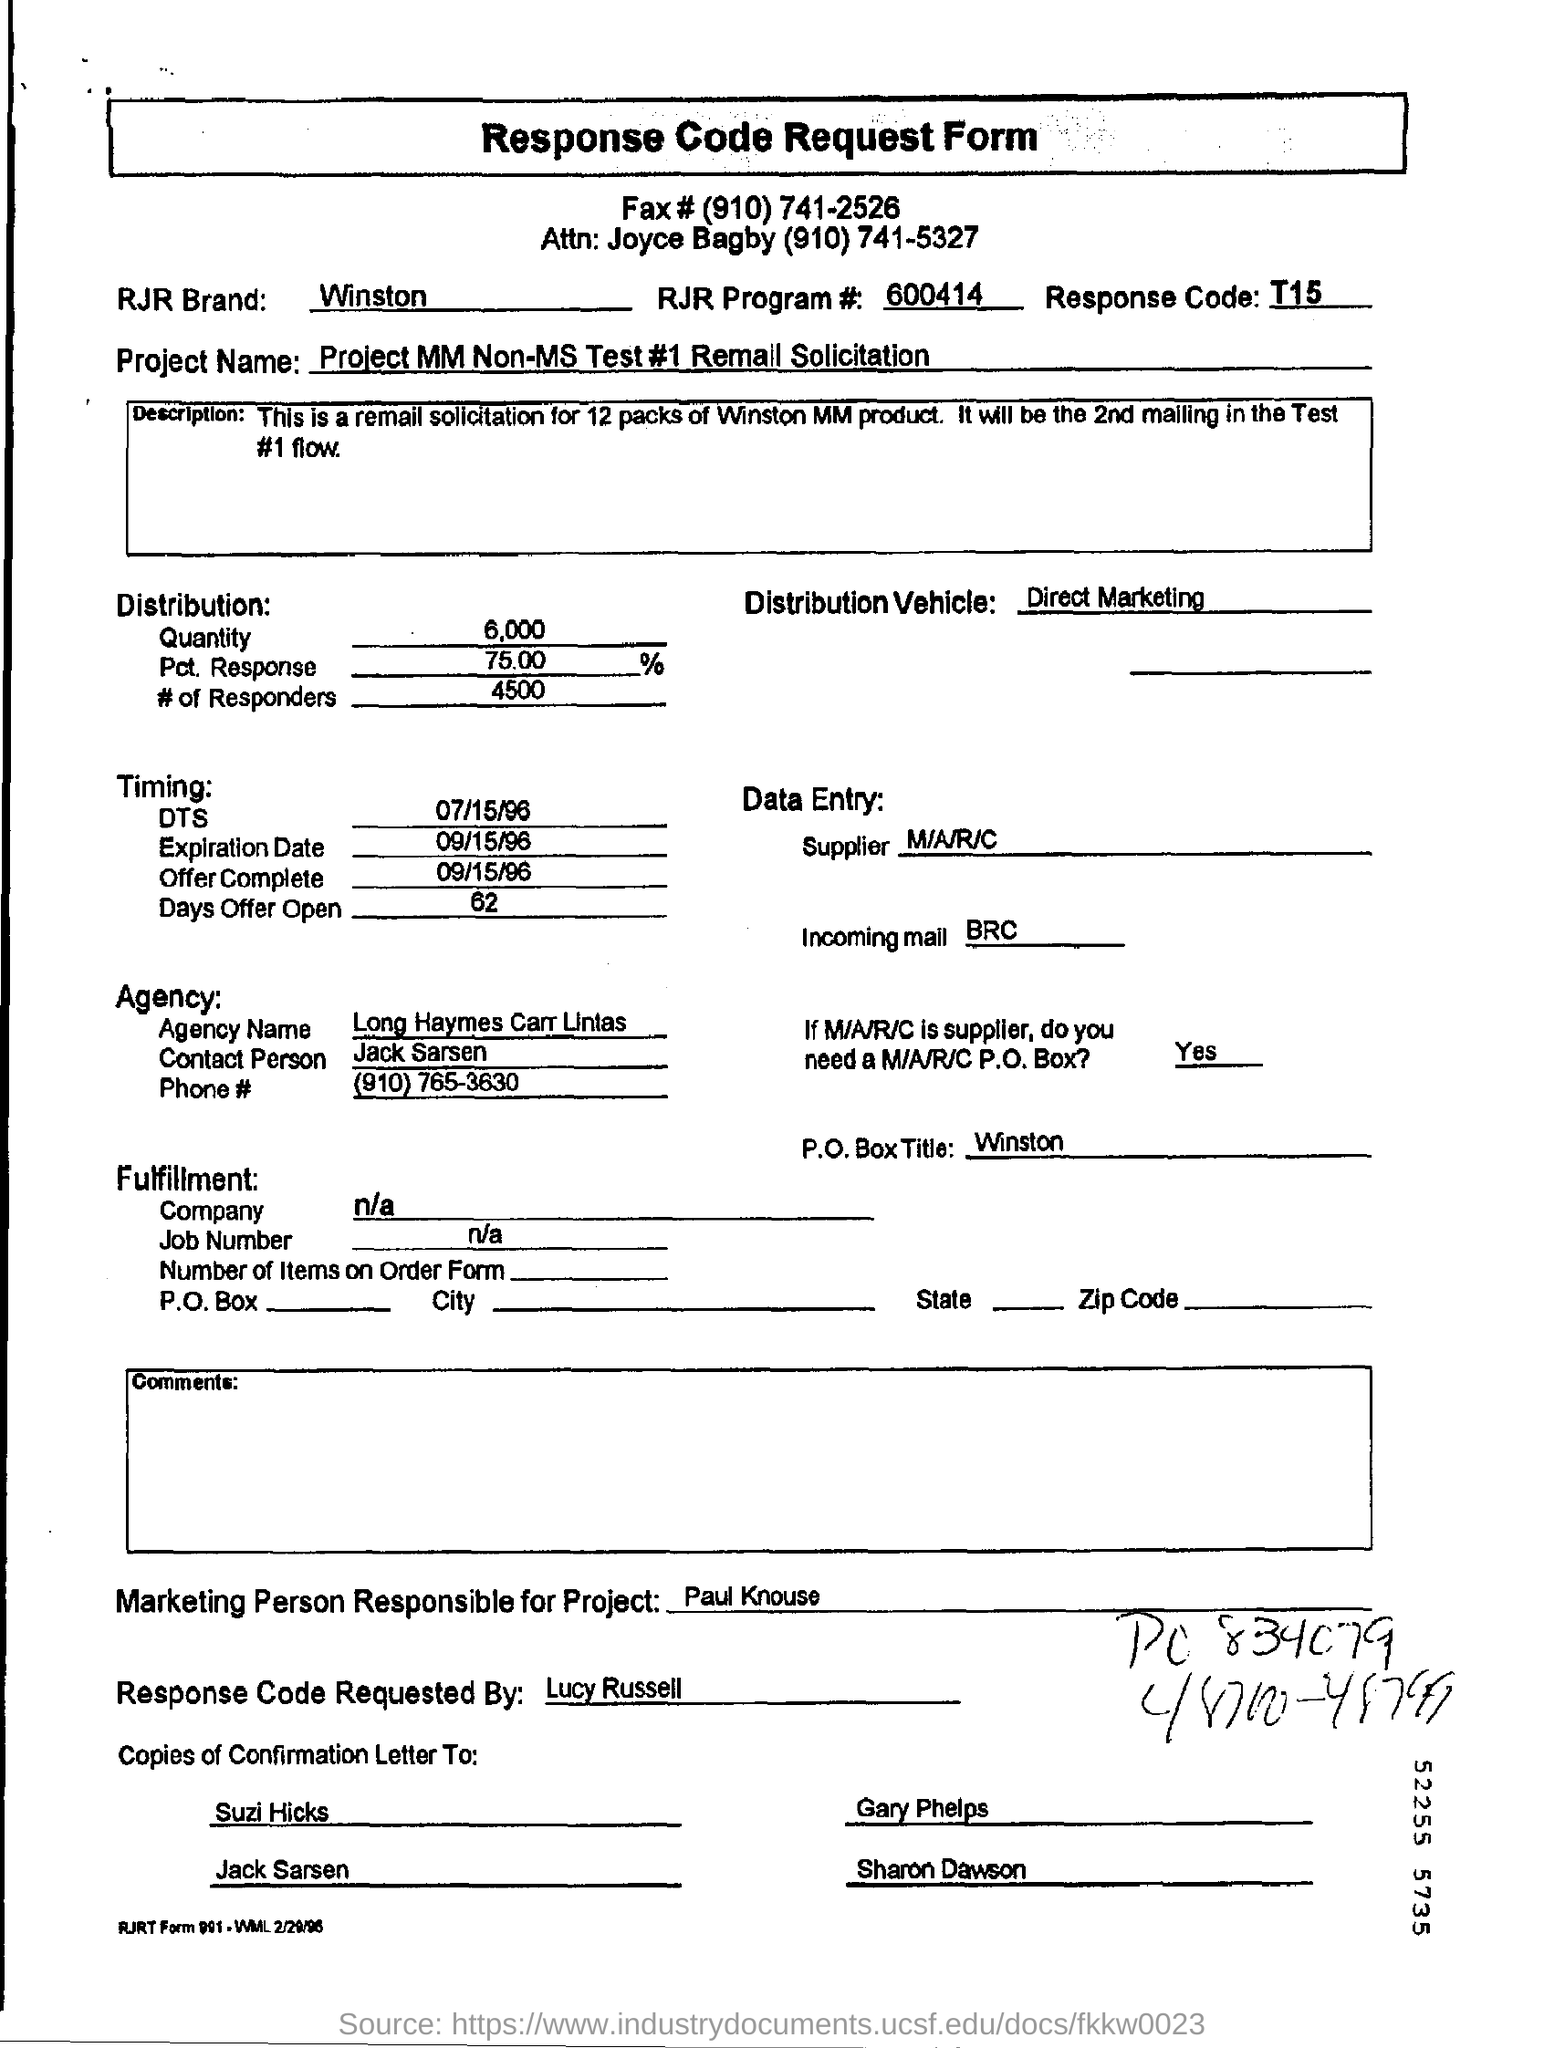List a handful of essential elements in this visual. The project name is "Remall Solicitation #1 for Non-MS Project in MM. The person responsible for project marketing is Paul Knouse. The response code was requested by Lucy Russell. This is a Request Form. 